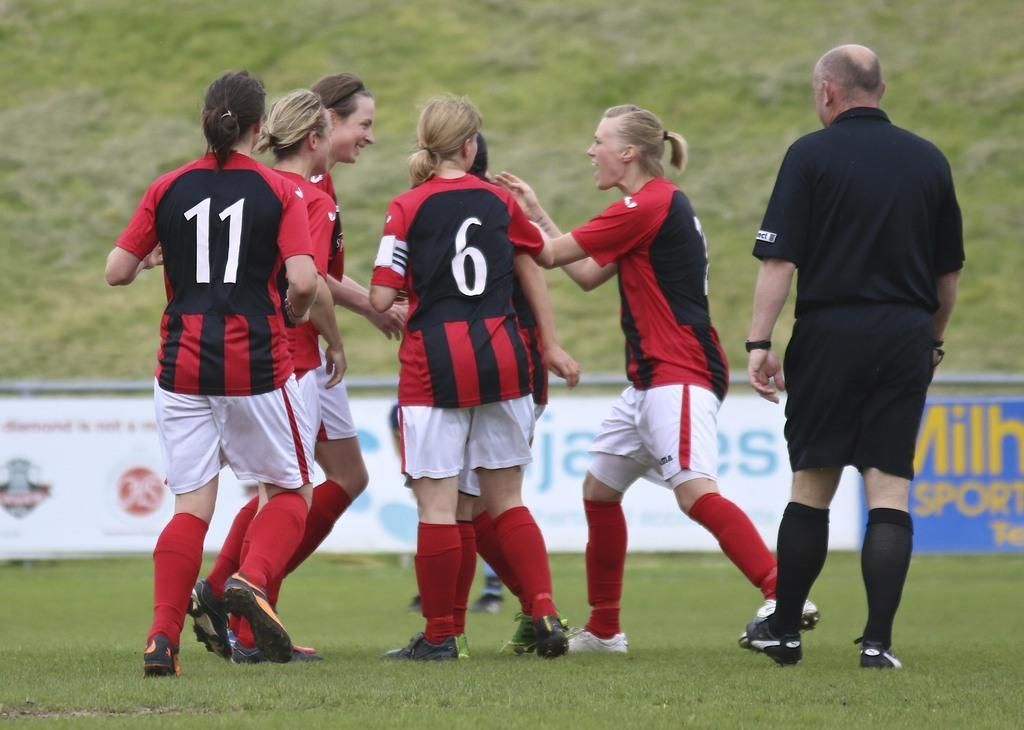<image>
Relay a brief, clear account of the picture shown. a soccer player group with one girl wearing the number 6 